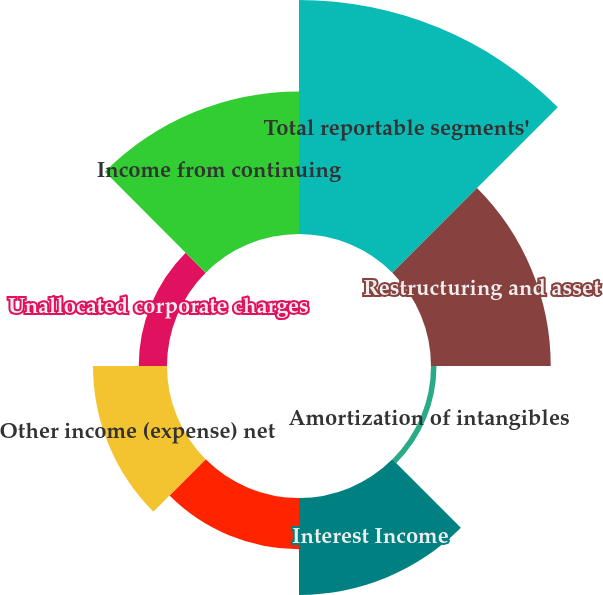<chart> <loc_0><loc_0><loc_500><loc_500><pie_chart><fcel>Total reportable segments'<fcel>Restructuring and asset<fcel>Amortization of intangibles<fcel>Interest Income<fcel>Interest Expense<fcel>Other income (expense) net<fcel>Unallocated corporate charges<fcel>Income from continuing<nl><fcel>31.11%<fcel>15.92%<fcel>0.73%<fcel>12.88%<fcel>6.8%<fcel>9.84%<fcel>3.76%<fcel>18.96%<nl></chart> 